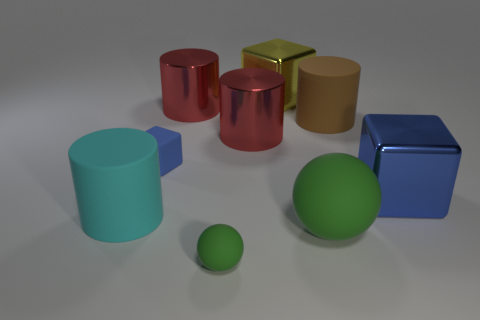There is a blue metal cube; is its size the same as the cylinder that is in front of the matte cube? Although at first glance it may seem that the size differs, upon closer inspection we can observe that the dimensions of the blue metal cube are indeed very similar to those of the cylinder in front of the matte cube. The slight differences in appearance might be due to perspective and the lighting conditions. 